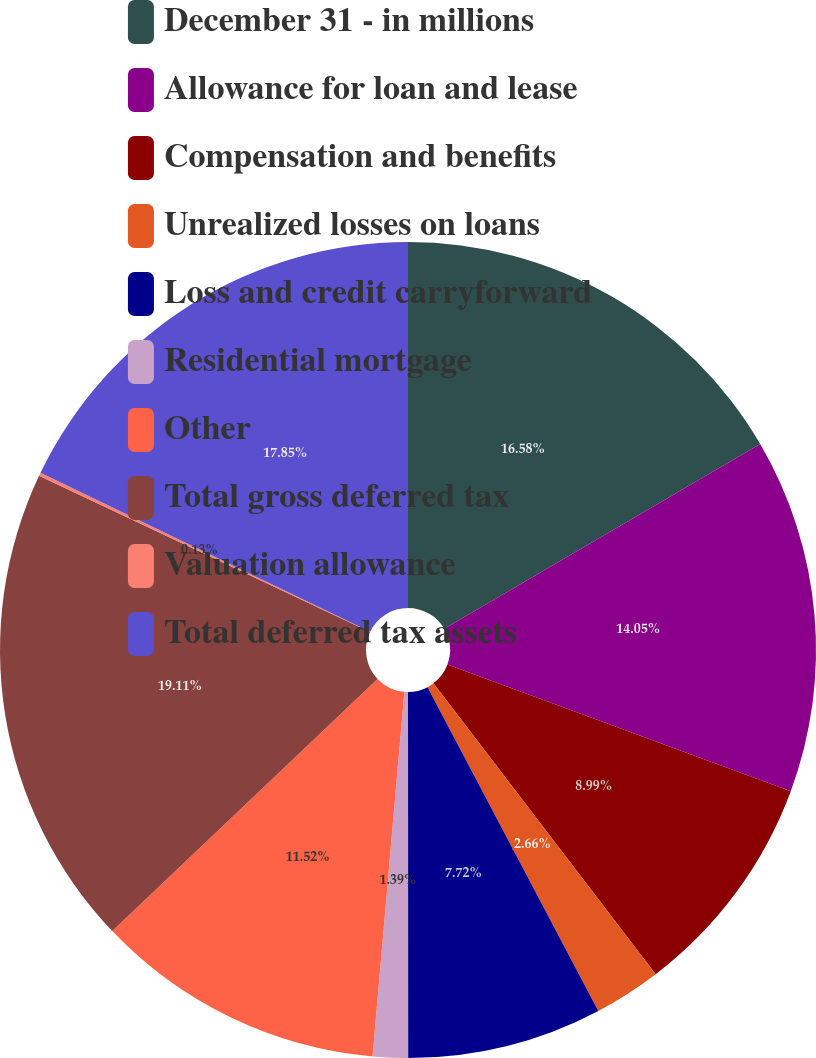<chart> <loc_0><loc_0><loc_500><loc_500><pie_chart><fcel>December 31 - in millions<fcel>Allowance for loan and lease<fcel>Compensation and benefits<fcel>Unrealized losses on loans<fcel>Loss and credit carryforward<fcel>Residential mortgage<fcel>Other<fcel>Total gross deferred tax<fcel>Valuation allowance<fcel>Total deferred tax assets<nl><fcel>16.58%<fcel>14.05%<fcel>8.99%<fcel>2.66%<fcel>7.72%<fcel>1.39%<fcel>11.52%<fcel>19.12%<fcel>0.13%<fcel>17.85%<nl></chart> 